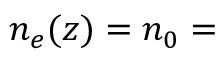Convert formula to latex. <formula><loc_0><loc_0><loc_500><loc_500>n _ { e } ( z ) = n _ { 0 } =</formula> 